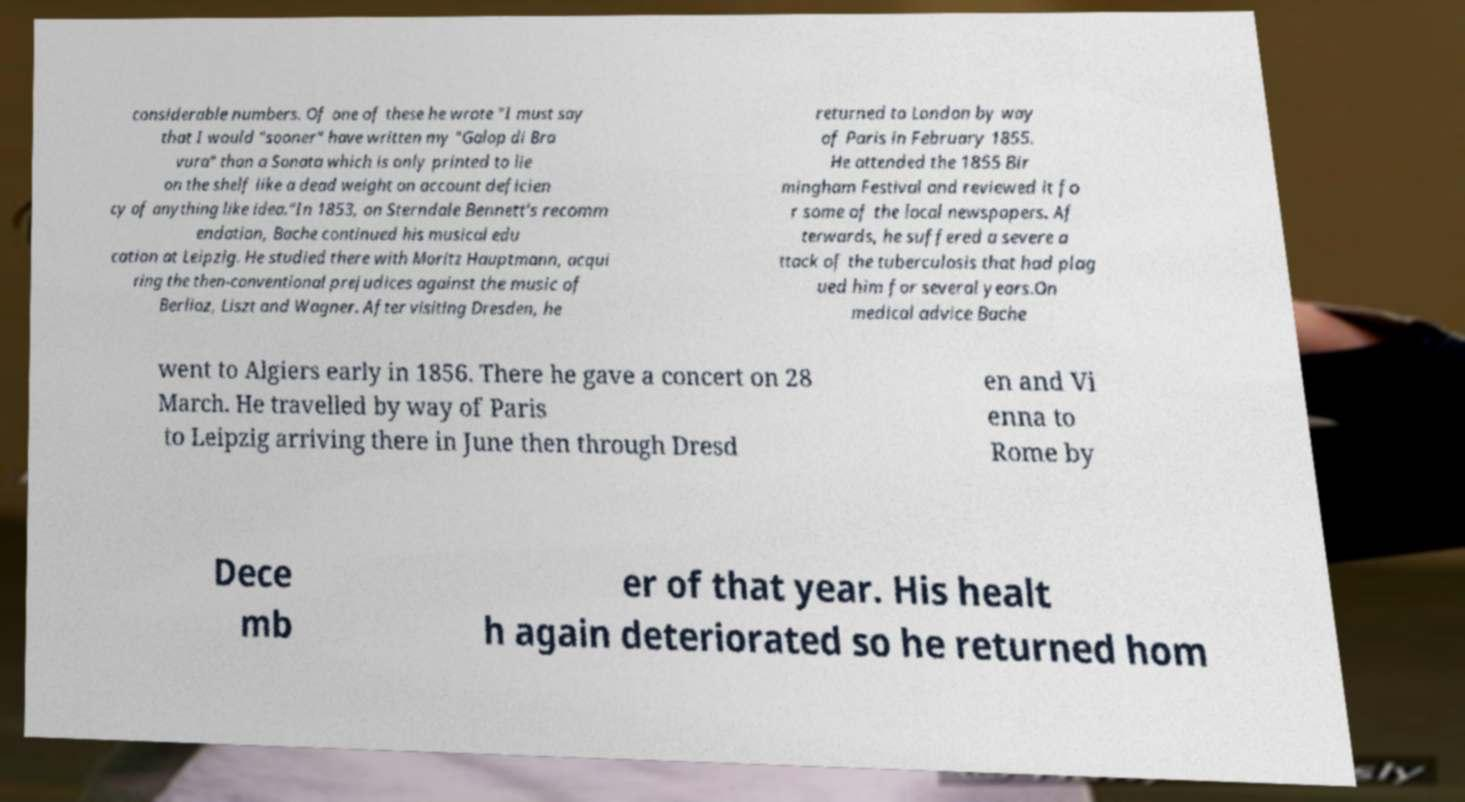Please identify and transcribe the text found in this image. considerable numbers. Of one of these he wrote "I must say that I would "sooner" have written my "Galop di Bra vura" than a Sonata which is only printed to lie on the shelf like a dead weight on account deficien cy of anything like idea."In 1853, on Sterndale Bennett's recomm endation, Bache continued his musical edu cation at Leipzig. He studied there with Moritz Hauptmann, acqui ring the then-conventional prejudices against the music of Berlioz, Liszt and Wagner. After visiting Dresden, he returned to London by way of Paris in February 1855. He attended the 1855 Bir mingham Festival and reviewed it fo r some of the local newspapers. Af terwards, he suffered a severe a ttack of the tuberculosis that had plag ued him for several years.On medical advice Bache went to Algiers early in 1856. There he gave a concert on 28 March. He travelled by way of Paris to Leipzig arriving there in June then through Dresd en and Vi enna to Rome by Dece mb er of that year. His healt h again deteriorated so he returned hom 